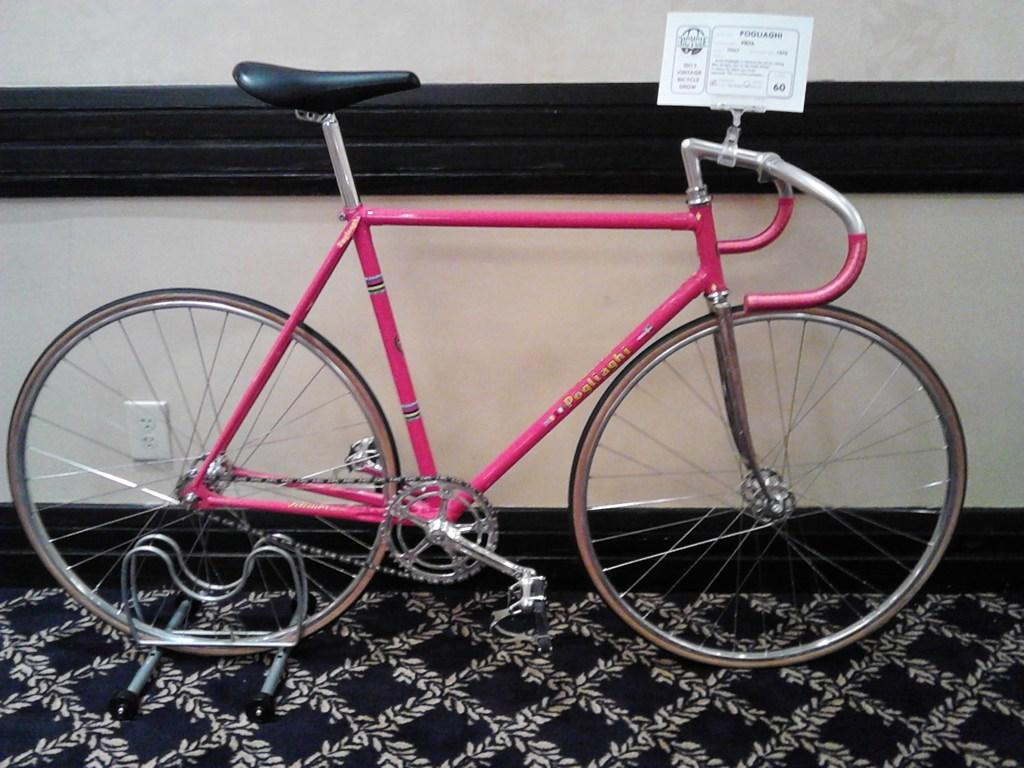What is the main object in the image? There is a cycle with a board on it in the image. What is located on the wall behind the cycle? There is a switchboard on the wall behind the cycle. What is on the floor at the bottom of the image? There is a mat on the floor at the bottom of the image. How many bones can be seen in the image? There are no bones visible in the image. What type of game is being played in the image? There is no game being played in the image. 